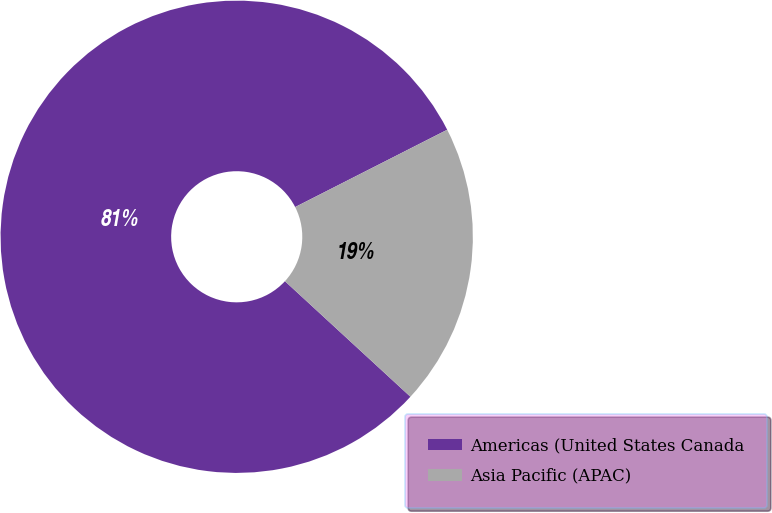Convert chart to OTSL. <chart><loc_0><loc_0><loc_500><loc_500><pie_chart><fcel>Americas (United States Canada<fcel>Asia Pacific (APAC)<nl><fcel>80.67%<fcel>19.33%<nl></chart> 